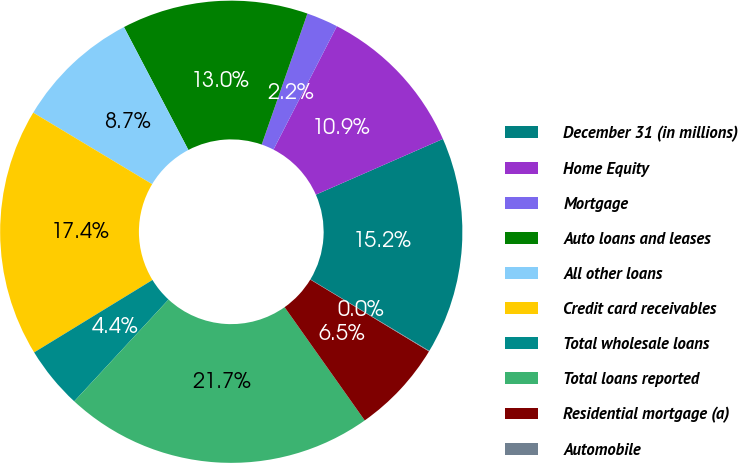<chart> <loc_0><loc_0><loc_500><loc_500><pie_chart><fcel>December 31 (in millions)<fcel>Home Equity<fcel>Mortgage<fcel>Auto loans and leases<fcel>All other loans<fcel>Credit card receivables<fcel>Total wholesale loans<fcel>Total loans reported<fcel>Residential mortgage (a)<fcel>Automobile<nl><fcel>15.2%<fcel>10.87%<fcel>2.21%<fcel>13.03%<fcel>8.7%<fcel>17.36%<fcel>4.37%<fcel>21.69%<fcel>6.54%<fcel>0.04%<nl></chart> 